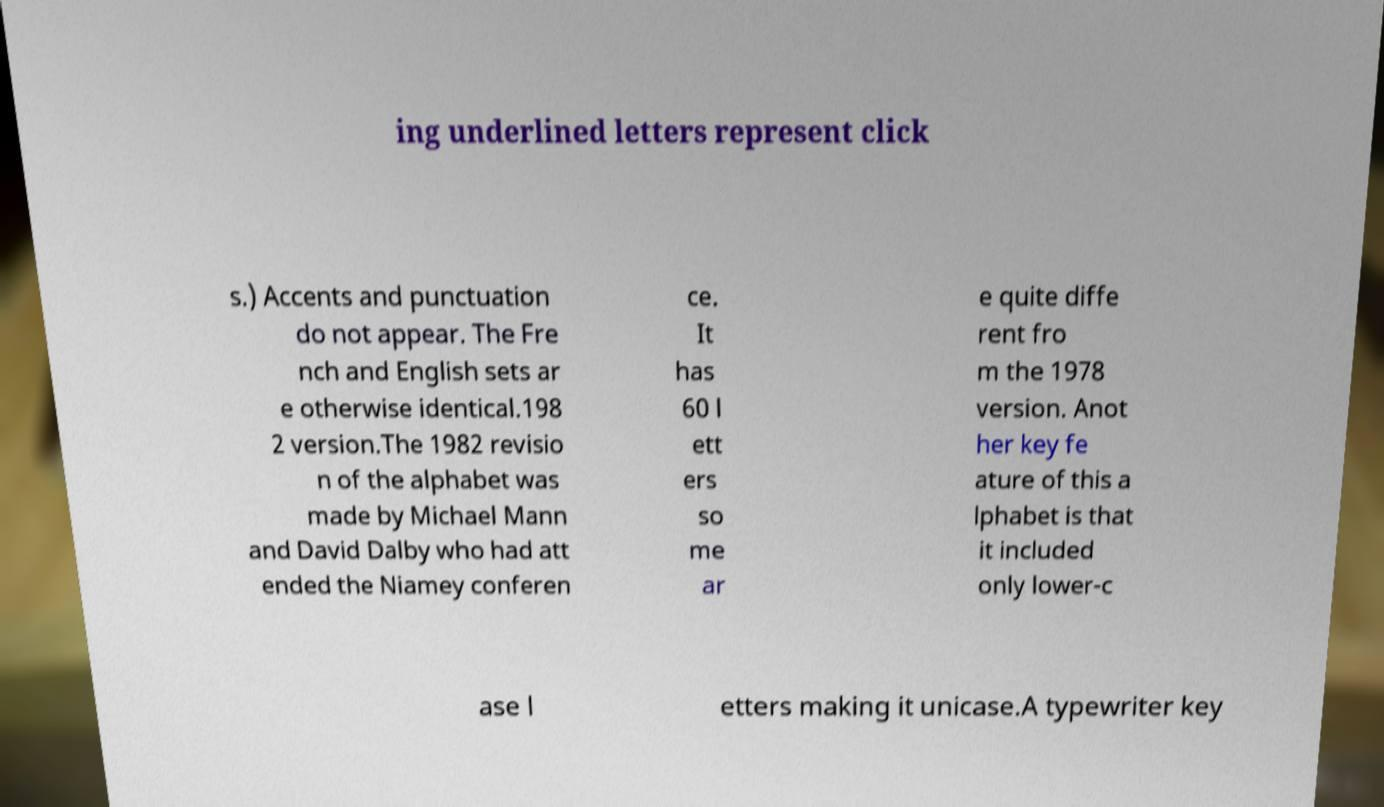What messages or text are displayed in this image? I need them in a readable, typed format. ing underlined letters represent click s.) Accents and punctuation do not appear. The Fre nch and English sets ar e otherwise identical.198 2 version.The 1982 revisio n of the alphabet was made by Michael Mann and David Dalby who had att ended the Niamey conferen ce. It has 60 l ett ers so me ar e quite diffe rent fro m the 1978 version. Anot her key fe ature of this a lphabet is that it included only lower-c ase l etters making it unicase.A typewriter key 